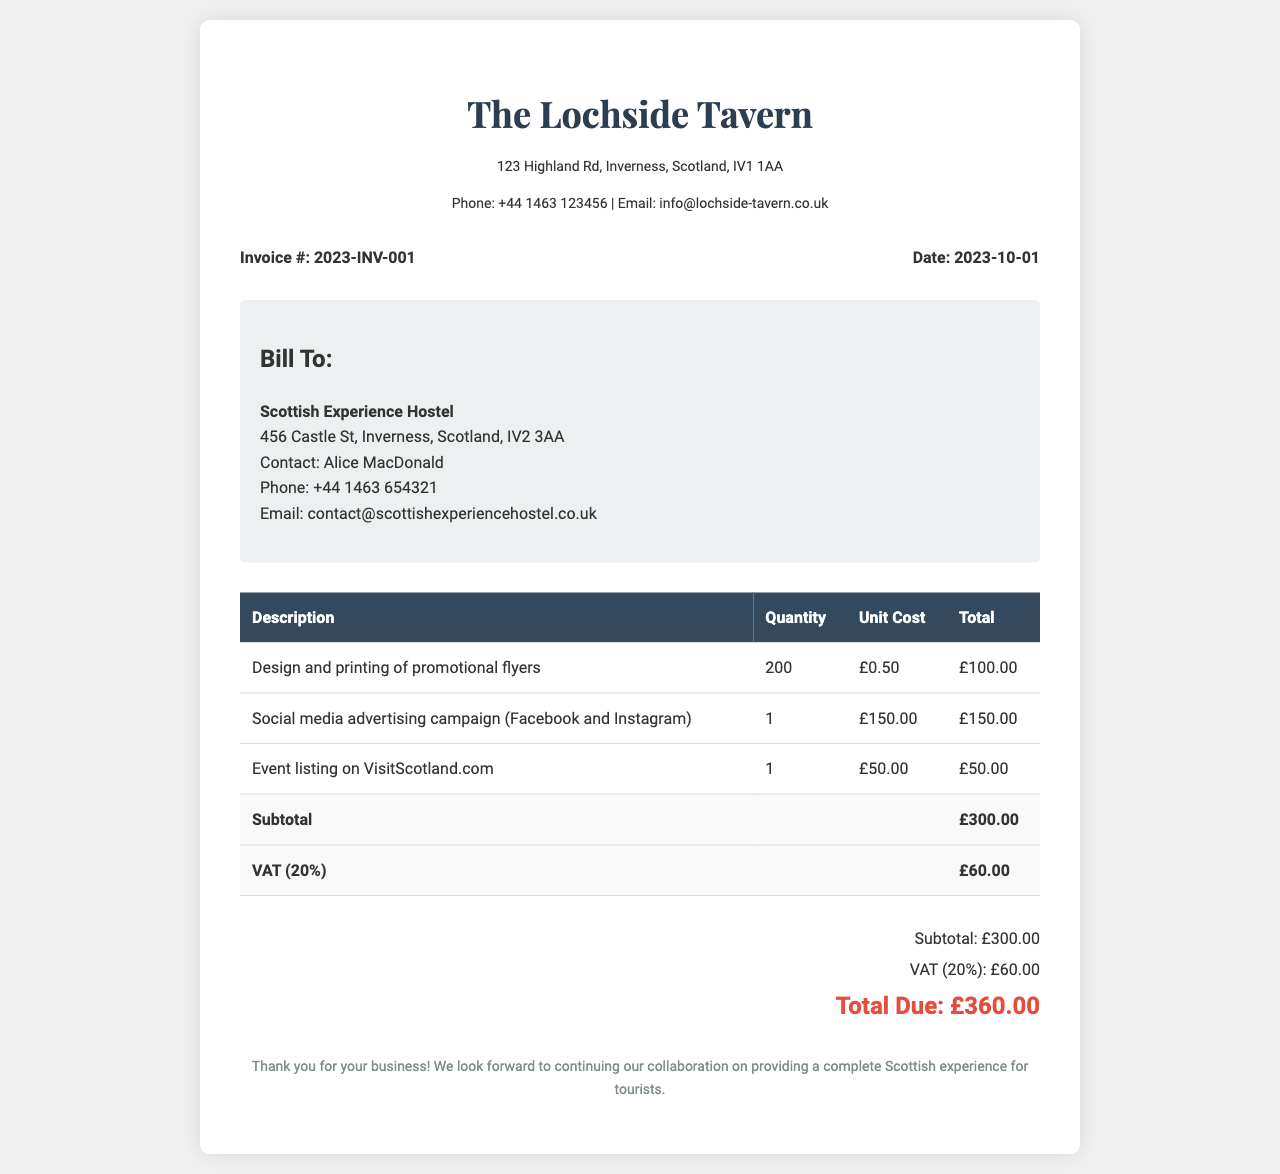What is the invoice number? The invoice number is located in the invoice details section.
Answer: 2023-INV-001 What is the date of the invoice? The date is also found in the invoice details section.
Answer: 2023-10-01 Who is billed for the promotional materials? The billing information is in the recipient info section.
Answer: Scottish Experience Hostel What is the total amount due? The total amount is located in the summary section of the invoice.
Answer: £360.00 How many promotional flyers were ordered? The quantity of flyers can be found in the table describing the items.
Answer: 200 What is the unit cost for social media advertising? The unit cost for social media advertising is specified in the items table.
Answer: £150.00 What is the VAT percentage applied to the invoice? The VAT percentage is explicitly mentioned in the invoice.
Answer: 20% What is the subtotal before VAT? The subtotal before VAT can be found in the summary of the invoice.
Answer: £300.00 What is the total amount for event listing? The total for event listing can be identified in the itemized list.
Answer: £50.00 